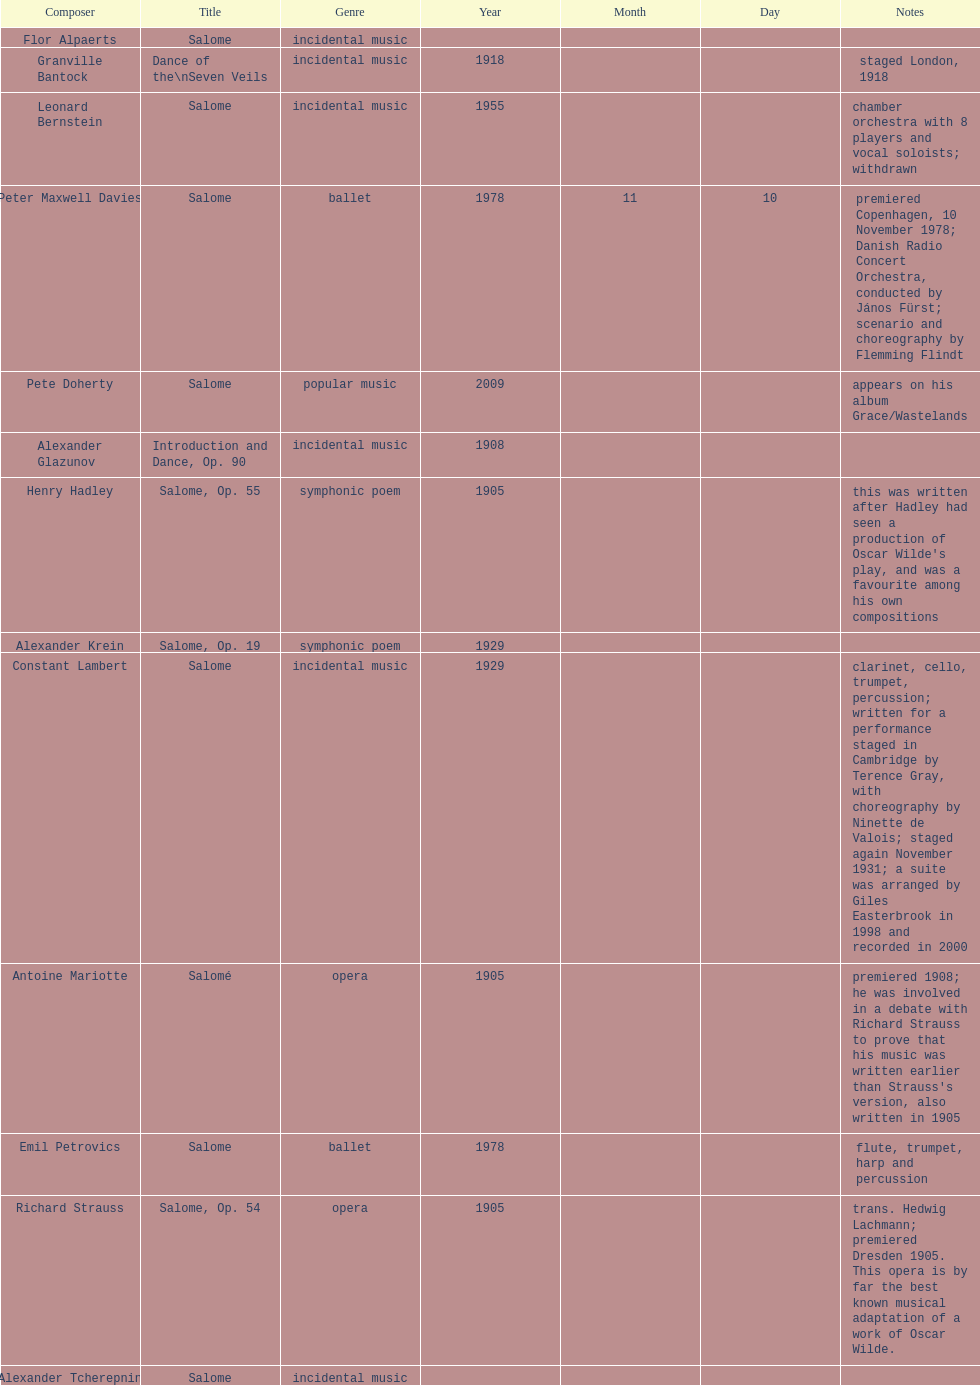What is the difference in years of granville bantock's work compared to pete dohert? 91. 